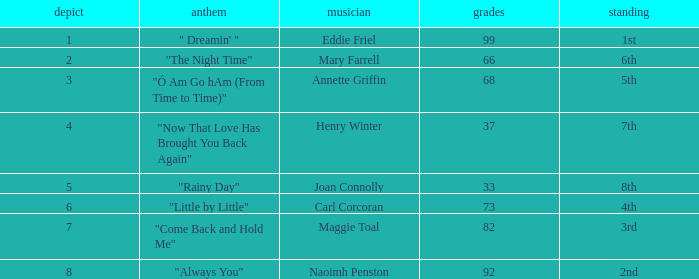What melody owns beyond 66 points, a stalemate surpassing 3, and is listed 3rd in the standings? "Come Back and Hold Me". 